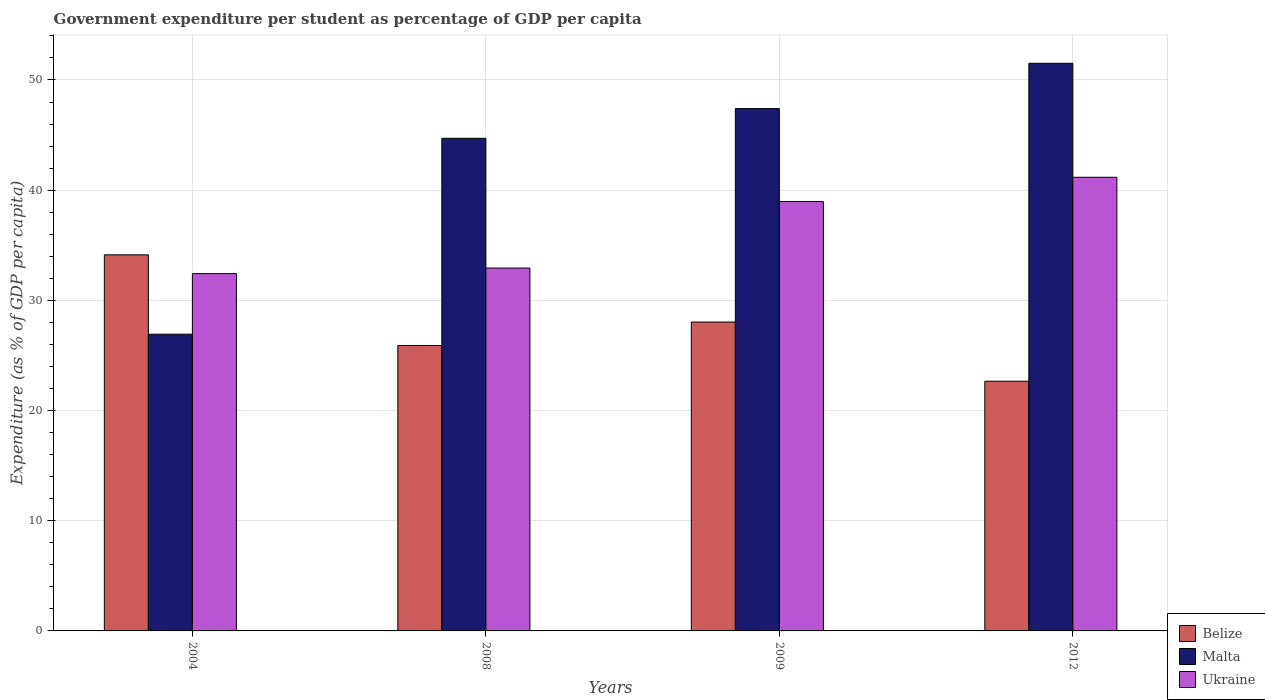How many groups of bars are there?
Ensure brevity in your answer.  4. Are the number of bars per tick equal to the number of legend labels?
Ensure brevity in your answer.  Yes. Are the number of bars on each tick of the X-axis equal?
Offer a terse response. Yes. How many bars are there on the 2nd tick from the left?
Make the answer very short. 3. How many bars are there on the 2nd tick from the right?
Ensure brevity in your answer.  3. What is the label of the 3rd group of bars from the left?
Your answer should be very brief. 2009. What is the percentage of expenditure per student in Ukraine in 2012?
Your answer should be compact. 41.17. Across all years, what is the maximum percentage of expenditure per student in Malta?
Offer a terse response. 51.52. Across all years, what is the minimum percentage of expenditure per student in Ukraine?
Ensure brevity in your answer.  32.43. In which year was the percentage of expenditure per student in Malta maximum?
Keep it short and to the point. 2012. In which year was the percentage of expenditure per student in Malta minimum?
Give a very brief answer. 2004. What is the total percentage of expenditure per student in Belize in the graph?
Give a very brief answer. 110.73. What is the difference between the percentage of expenditure per student in Ukraine in 2004 and that in 2008?
Offer a terse response. -0.51. What is the difference between the percentage of expenditure per student in Malta in 2012 and the percentage of expenditure per student in Belize in 2004?
Make the answer very short. 17.39. What is the average percentage of expenditure per student in Belize per year?
Offer a terse response. 27.68. In the year 2004, what is the difference between the percentage of expenditure per student in Ukraine and percentage of expenditure per student in Belize?
Make the answer very short. -1.7. In how many years, is the percentage of expenditure per student in Ukraine greater than 50 %?
Keep it short and to the point. 0. What is the ratio of the percentage of expenditure per student in Belize in 2008 to that in 2012?
Your answer should be compact. 1.14. Is the percentage of expenditure per student in Ukraine in 2009 less than that in 2012?
Provide a short and direct response. Yes. Is the difference between the percentage of expenditure per student in Ukraine in 2004 and 2009 greater than the difference between the percentage of expenditure per student in Belize in 2004 and 2009?
Provide a succinct answer. No. What is the difference between the highest and the second highest percentage of expenditure per student in Malta?
Your response must be concise. 4.11. What is the difference between the highest and the lowest percentage of expenditure per student in Ukraine?
Provide a succinct answer. 8.74. Is the sum of the percentage of expenditure per student in Malta in 2004 and 2008 greater than the maximum percentage of expenditure per student in Ukraine across all years?
Your response must be concise. Yes. What does the 2nd bar from the left in 2004 represents?
Offer a very short reply. Malta. What does the 3rd bar from the right in 2004 represents?
Your answer should be compact. Belize. Are all the bars in the graph horizontal?
Keep it short and to the point. No. What is the difference between two consecutive major ticks on the Y-axis?
Ensure brevity in your answer.  10. Are the values on the major ticks of Y-axis written in scientific E-notation?
Provide a short and direct response. No. Does the graph contain grids?
Ensure brevity in your answer.  Yes. How many legend labels are there?
Your answer should be very brief. 3. What is the title of the graph?
Offer a very short reply. Government expenditure per student as percentage of GDP per capita. What is the label or title of the Y-axis?
Ensure brevity in your answer.  Expenditure (as % of GDP per capita). What is the Expenditure (as % of GDP per capita) in Belize in 2004?
Your answer should be very brief. 34.13. What is the Expenditure (as % of GDP per capita) of Malta in 2004?
Provide a short and direct response. 26.93. What is the Expenditure (as % of GDP per capita) of Ukraine in 2004?
Offer a very short reply. 32.43. What is the Expenditure (as % of GDP per capita) of Belize in 2008?
Offer a very short reply. 25.9. What is the Expenditure (as % of GDP per capita) of Malta in 2008?
Provide a short and direct response. 44.71. What is the Expenditure (as % of GDP per capita) of Ukraine in 2008?
Provide a succinct answer. 32.93. What is the Expenditure (as % of GDP per capita) in Belize in 2009?
Offer a terse response. 28.03. What is the Expenditure (as % of GDP per capita) of Malta in 2009?
Make the answer very short. 47.4. What is the Expenditure (as % of GDP per capita) in Ukraine in 2009?
Make the answer very short. 38.97. What is the Expenditure (as % of GDP per capita) of Belize in 2012?
Keep it short and to the point. 22.66. What is the Expenditure (as % of GDP per capita) of Malta in 2012?
Provide a succinct answer. 51.52. What is the Expenditure (as % of GDP per capita) of Ukraine in 2012?
Your answer should be very brief. 41.17. Across all years, what is the maximum Expenditure (as % of GDP per capita) in Belize?
Offer a very short reply. 34.13. Across all years, what is the maximum Expenditure (as % of GDP per capita) in Malta?
Ensure brevity in your answer.  51.52. Across all years, what is the maximum Expenditure (as % of GDP per capita) of Ukraine?
Make the answer very short. 41.17. Across all years, what is the minimum Expenditure (as % of GDP per capita) of Belize?
Ensure brevity in your answer.  22.66. Across all years, what is the minimum Expenditure (as % of GDP per capita) in Malta?
Provide a succinct answer. 26.93. Across all years, what is the minimum Expenditure (as % of GDP per capita) of Ukraine?
Your answer should be compact. 32.43. What is the total Expenditure (as % of GDP per capita) of Belize in the graph?
Provide a succinct answer. 110.73. What is the total Expenditure (as % of GDP per capita) in Malta in the graph?
Your answer should be compact. 170.56. What is the total Expenditure (as % of GDP per capita) of Ukraine in the graph?
Make the answer very short. 145.51. What is the difference between the Expenditure (as % of GDP per capita) of Belize in 2004 and that in 2008?
Your answer should be very brief. 8.23. What is the difference between the Expenditure (as % of GDP per capita) of Malta in 2004 and that in 2008?
Your answer should be very brief. -17.78. What is the difference between the Expenditure (as % of GDP per capita) of Ukraine in 2004 and that in 2008?
Your response must be concise. -0.51. What is the difference between the Expenditure (as % of GDP per capita) in Belize in 2004 and that in 2009?
Provide a succinct answer. 6.1. What is the difference between the Expenditure (as % of GDP per capita) in Malta in 2004 and that in 2009?
Ensure brevity in your answer.  -20.48. What is the difference between the Expenditure (as % of GDP per capita) of Ukraine in 2004 and that in 2009?
Your response must be concise. -6.55. What is the difference between the Expenditure (as % of GDP per capita) in Belize in 2004 and that in 2012?
Make the answer very short. 11.47. What is the difference between the Expenditure (as % of GDP per capita) of Malta in 2004 and that in 2012?
Provide a succinct answer. -24.59. What is the difference between the Expenditure (as % of GDP per capita) of Ukraine in 2004 and that in 2012?
Offer a very short reply. -8.74. What is the difference between the Expenditure (as % of GDP per capita) in Belize in 2008 and that in 2009?
Your answer should be compact. -2.13. What is the difference between the Expenditure (as % of GDP per capita) in Malta in 2008 and that in 2009?
Give a very brief answer. -2.7. What is the difference between the Expenditure (as % of GDP per capita) in Ukraine in 2008 and that in 2009?
Offer a terse response. -6.04. What is the difference between the Expenditure (as % of GDP per capita) of Belize in 2008 and that in 2012?
Offer a terse response. 3.24. What is the difference between the Expenditure (as % of GDP per capita) in Malta in 2008 and that in 2012?
Keep it short and to the point. -6.81. What is the difference between the Expenditure (as % of GDP per capita) of Ukraine in 2008 and that in 2012?
Keep it short and to the point. -8.24. What is the difference between the Expenditure (as % of GDP per capita) in Belize in 2009 and that in 2012?
Give a very brief answer. 5.37. What is the difference between the Expenditure (as % of GDP per capita) in Malta in 2009 and that in 2012?
Ensure brevity in your answer.  -4.11. What is the difference between the Expenditure (as % of GDP per capita) in Ukraine in 2009 and that in 2012?
Your answer should be very brief. -2.2. What is the difference between the Expenditure (as % of GDP per capita) in Belize in 2004 and the Expenditure (as % of GDP per capita) in Malta in 2008?
Offer a terse response. -10.58. What is the difference between the Expenditure (as % of GDP per capita) in Belize in 2004 and the Expenditure (as % of GDP per capita) in Ukraine in 2008?
Provide a succinct answer. 1.2. What is the difference between the Expenditure (as % of GDP per capita) of Malta in 2004 and the Expenditure (as % of GDP per capita) of Ukraine in 2008?
Give a very brief answer. -6.01. What is the difference between the Expenditure (as % of GDP per capita) of Belize in 2004 and the Expenditure (as % of GDP per capita) of Malta in 2009?
Ensure brevity in your answer.  -13.27. What is the difference between the Expenditure (as % of GDP per capita) of Belize in 2004 and the Expenditure (as % of GDP per capita) of Ukraine in 2009?
Provide a succinct answer. -4.84. What is the difference between the Expenditure (as % of GDP per capita) in Malta in 2004 and the Expenditure (as % of GDP per capita) in Ukraine in 2009?
Offer a very short reply. -12.05. What is the difference between the Expenditure (as % of GDP per capita) in Belize in 2004 and the Expenditure (as % of GDP per capita) in Malta in 2012?
Your answer should be very brief. -17.39. What is the difference between the Expenditure (as % of GDP per capita) in Belize in 2004 and the Expenditure (as % of GDP per capita) in Ukraine in 2012?
Offer a terse response. -7.04. What is the difference between the Expenditure (as % of GDP per capita) in Malta in 2004 and the Expenditure (as % of GDP per capita) in Ukraine in 2012?
Offer a very short reply. -14.24. What is the difference between the Expenditure (as % of GDP per capita) of Belize in 2008 and the Expenditure (as % of GDP per capita) of Malta in 2009?
Offer a terse response. -21.5. What is the difference between the Expenditure (as % of GDP per capita) in Belize in 2008 and the Expenditure (as % of GDP per capita) in Ukraine in 2009?
Ensure brevity in your answer.  -13.07. What is the difference between the Expenditure (as % of GDP per capita) of Malta in 2008 and the Expenditure (as % of GDP per capita) of Ukraine in 2009?
Provide a short and direct response. 5.73. What is the difference between the Expenditure (as % of GDP per capita) of Belize in 2008 and the Expenditure (as % of GDP per capita) of Malta in 2012?
Your answer should be compact. -25.62. What is the difference between the Expenditure (as % of GDP per capita) in Belize in 2008 and the Expenditure (as % of GDP per capita) in Ukraine in 2012?
Your answer should be compact. -15.27. What is the difference between the Expenditure (as % of GDP per capita) in Malta in 2008 and the Expenditure (as % of GDP per capita) in Ukraine in 2012?
Give a very brief answer. 3.54. What is the difference between the Expenditure (as % of GDP per capita) of Belize in 2009 and the Expenditure (as % of GDP per capita) of Malta in 2012?
Offer a very short reply. -23.49. What is the difference between the Expenditure (as % of GDP per capita) in Belize in 2009 and the Expenditure (as % of GDP per capita) in Ukraine in 2012?
Make the answer very short. -13.14. What is the difference between the Expenditure (as % of GDP per capita) of Malta in 2009 and the Expenditure (as % of GDP per capita) of Ukraine in 2012?
Your answer should be compact. 6.23. What is the average Expenditure (as % of GDP per capita) of Belize per year?
Provide a short and direct response. 27.68. What is the average Expenditure (as % of GDP per capita) in Malta per year?
Offer a very short reply. 42.64. What is the average Expenditure (as % of GDP per capita) in Ukraine per year?
Your answer should be compact. 36.38. In the year 2004, what is the difference between the Expenditure (as % of GDP per capita) of Belize and Expenditure (as % of GDP per capita) of Malta?
Provide a succinct answer. 7.2. In the year 2004, what is the difference between the Expenditure (as % of GDP per capita) of Belize and Expenditure (as % of GDP per capita) of Ukraine?
Offer a very short reply. 1.7. In the year 2004, what is the difference between the Expenditure (as % of GDP per capita) of Malta and Expenditure (as % of GDP per capita) of Ukraine?
Offer a very short reply. -5.5. In the year 2008, what is the difference between the Expenditure (as % of GDP per capita) of Belize and Expenditure (as % of GDP per capita) of Malta?
Keep it short and to the point. -18.8. In the year 2008, what is the difference between the Expenditure (as % of GDP per capita) in Belize and Expenditure (as % of GDP per capita) in Ukraine?
Your answer should be very brief. -7.03. In the year 2008, what is the difference between the Expenditure (as % of GDP per capita) in Malta and Expenditure (as % of GDP per capita) in Ukraine?
Make the answer very short. 11.77. In the year 2009, what is the difference between the Expenditure (as % of GDP per capita) in Belize and Expenditure (as % of GDP per capita) in Malta?
Offer a terse response. -19.37. In the year 2009, what is the difference between the Expenditure (as % of GDP per capita) of Belize and Expenditure (as % of GDP per capita) of Ukraine?
Provide a short and direct response. -10.94. In the year 2009, what is the difference between the Expenditure (as % of GDP per capita) in Malta and Expenditure (as % of GDP per capita) in Ukraine?
Give a very brief answer. 8.43. In the year 2012, what is the difference between the Expenditure (as % of GDP per capita) of Belize and Expenditure (as % of GDP per capita) of Malta?
Give a very brief answer. -28.86. In the year 2012, what is the difference between the Expenditure (as % of GDP per capita) of Belize and Expenditure (as % of GDP per capita) of Ukraine?
Provide a short and direct response. -18.51. In the year 2012, what is the difference between the Expenditure (as % of GDP per capita) in Malta and Expenditure (as % of GDP per capita) in Ukraine?
Give a very brief answer. 10.35. What is the ratio of the Expenditure (as % of GDP per capita) of Belize in 2004 to that in 2008?
Your answer should be very brief. 1.32. What is the ratio of the Expenditure (as % of GDP per capita) in Malta in 2004 to that in 2008?
Offer a very short reply. 0.6. What is the ratio of the Expenditure (as % of GDP per capita) in Ukraine in 2004 to that in 2008?
Your response must be concise. 0.98. What is the ratio of the Expenditure (as % of GDP per capita) in Belize in 2004 to that in 2009?
Your answer should be very brief. 1.22. What is the ratio of the Expenditure (as % of GDP per capita) in Malta in 2004 to that in 2009?
Keep it short and to the point. 0.57. What is the ratio of the Expenditure (as % of GDP per capita) of Ukraine in 2004 to that in 2009?
Your answer should be very brief. 0.83. What is the ratio of the Expenditure (as % of GDP per capita) of Belize in 2004 to that in 2012?
Provide a succinct answer. 1.51. What is the ratio of the Expenditure (as % of GDP per capita) of Malta in 2004 to that in 2012?
Provide a succinct answer. 0.52. What is the ratio of the Expenditure (as % of GDP per capita) in Ukraine in 2004 to that in 2012?
Keep it short and to the point. 0.79. What is the ratio of the Expenditure (as % of GDP per capita) in Belize in 2008 to that in 2009?
Make the answer very short. 0.92. What is the ratio of the Expenditure (as % of GDP per capita) of Malta in 2008 to that in 2009?
Offer a terse response. 0.94. What is the ratio of the Expenditure (as % of GDP per capita) in Ukraine in 2008 to that in 2009?
Make the answer very short. 0.84. What is the ratio of the Expenditure (as % of GDP per capita) of Belize in 2008 to that in 2012?
Ensure brevity in your answer.  1.14. What is the ratio of the Expenditure (as % of GDP per capita) of Malta in 2008 to that in 2012?
Ensure brevity in your answer.  0.87. What is the ratio of the Expenditure (as % of GDP per capita) of Ukraine in 2008 to that in 2012?
Give a very brief answer. 0.8. What is the ratio of the Expenditure (as % of GDP per capita) in Belize in 2009 to that in 2012?
Your answer should be compact. 1.24. What is the ratio of the Expenditure (as % of GDP per capita) of Malta in 2009 to that in 2012?
Provide a succinct answer. 0.92. What is the ratio of the Expenditure (as % of GDP per capita) of Ukraine in 2009 to that in 2012?
Your response must be concise. 0.95. What is the difference between the highest and the second highest Expenditure (as % of GDP per capita) in Belize?
Provide a short and direct response. 6.1. What is the difference between the highest and the second highest Expenditure (as % of GDP per capita) in Malta?
Your response must be concise. 4.11. What is the difference between the highest and the second highest Expenditure (as % of GDP per capita) of Ukraine?
Offer a very short reply. 2.2. What is the difference between the highest and the lowest Expenditure (as % of GDP per capita) of Belize?
Offer a very short reply. 11.47. What is the difference between the highest and the lowest Expenditure (as % of GDP per capita) of Malta?
Make the answer very short. 24.59. What is the difference between the highest and the lowest Expenditure (as % of GDP per capita) of Ukraine?
Ensure brevity in your answer.  8.74. 